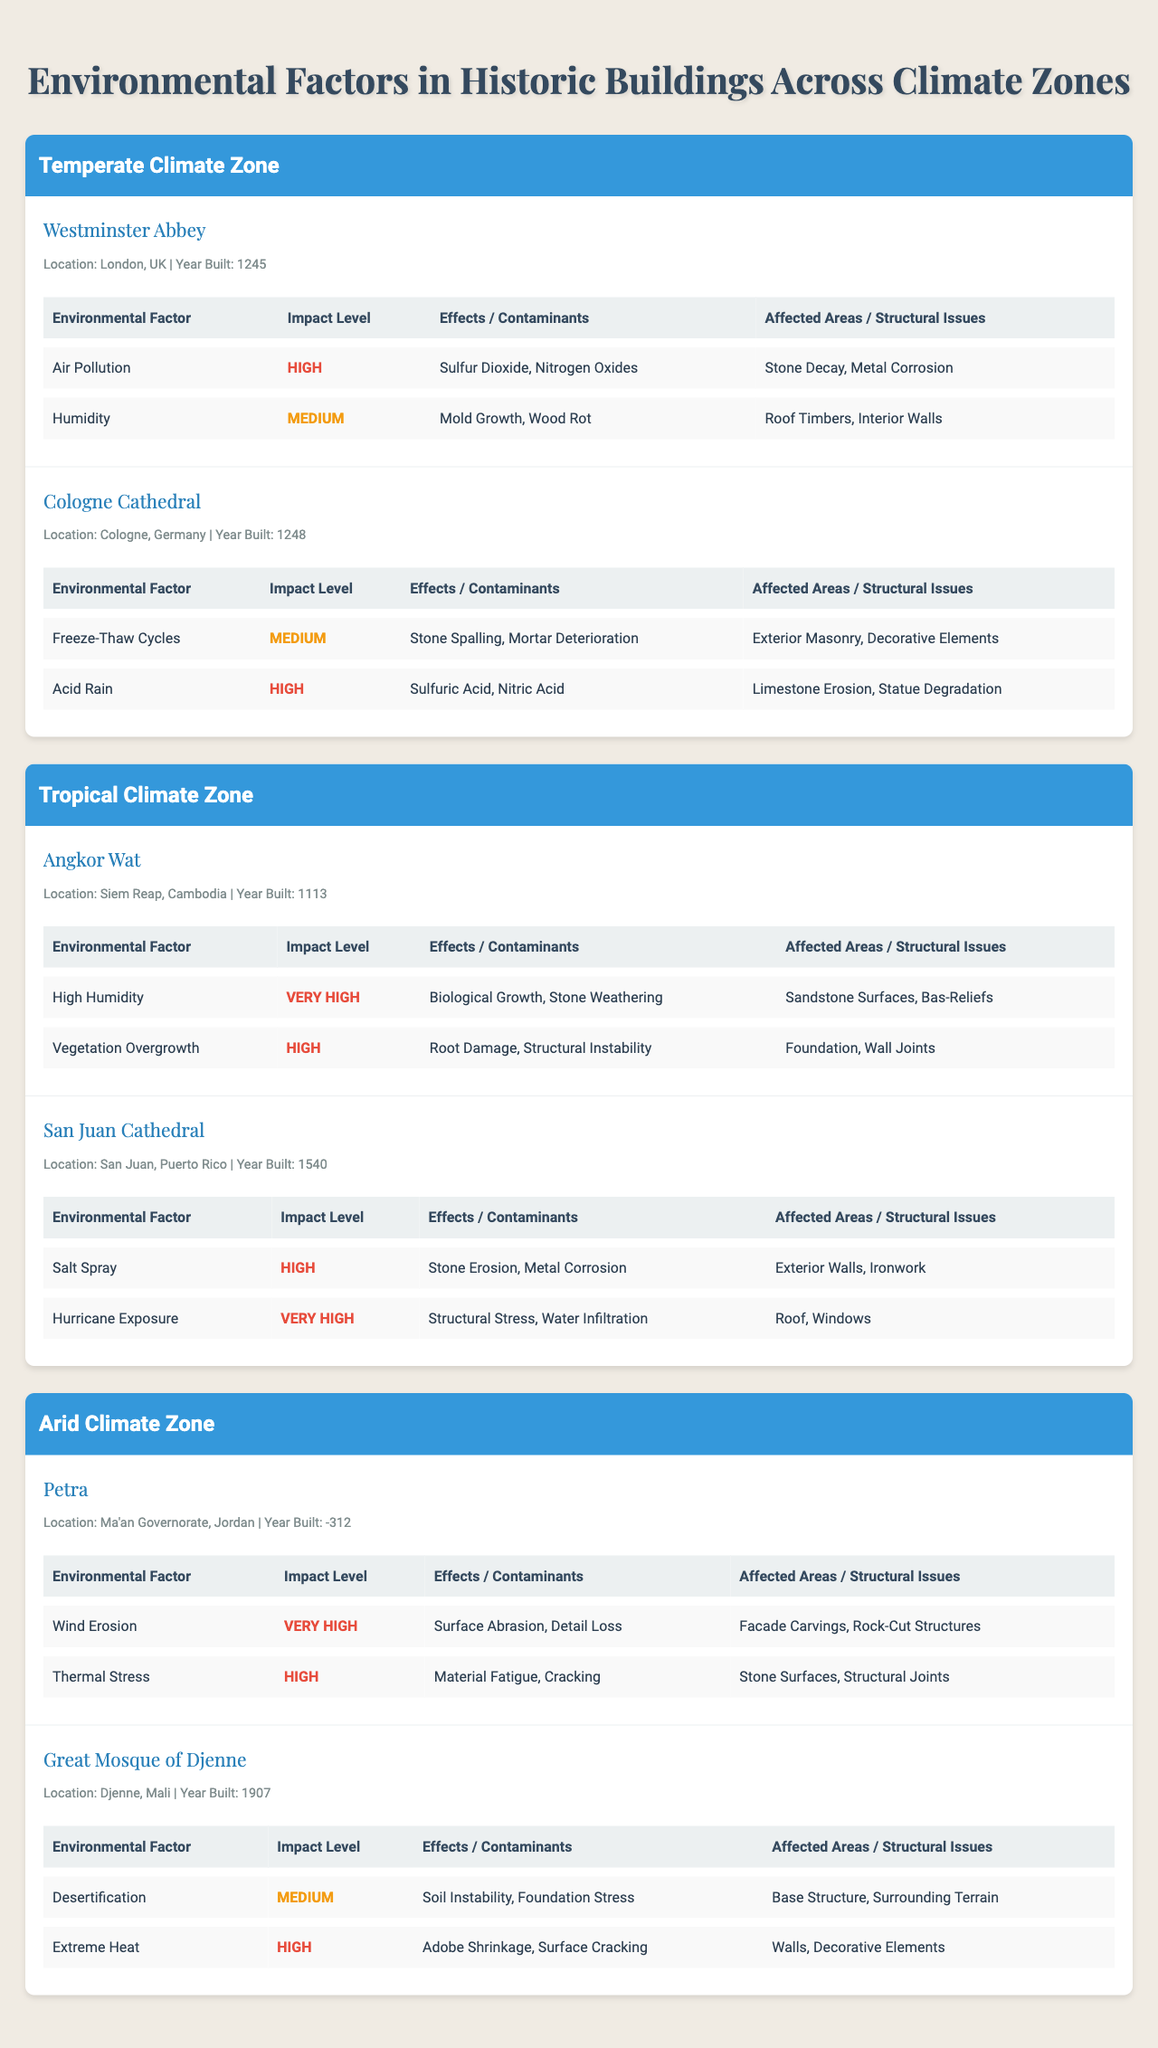What is the highest impact level for environmental factors affecting Westminster Abbey? The table shows that Westminster Abbey has two environmental factors: "Air Pollution" with a "High" impact level and "Humidity" with a "Medium" impact level. The highest impact level here is "High."
Answer: High Which building was built earlier, Angkor Wat or Cologne Cathedral? Angkor Wat was built in 1113, while Cologne Cathedral was built in 1248. Since 1113 is earlier than 1248, Angkor Wat is the earlier building.
Answer: Angkor Wat How many buildings in the Tropical climate zone have an environmental factor with a "Very High" impact level? In the Tropical climate zone, Angkor Wat has a "Very High" impact level for "High Humidity," and San Juan Cathedral has "Hurricane Exposure" also at a "Very High" level. Therefore, there are 2 buildings with this designation.
Answer: 2 What is the main contaminant associated with the "Acid Rain" environmental factor for Cologne Cathedral? The table indicates that the main contaminants for "Acid Rain" impacting Cologne Cathedral are "Sulfuric Acid" and "Nitric Acid." So, the main contaminants are both listed.
Answer: Sulfuric Acid, Nitric Acid For the Arid climate zone, what structural issue is associated with "Wind Erosion" for Petra? According to the table, the structural issues caused by "Wind Erosion" for Petra include "Surface Abrasion" and "Detail Loss."
Answer: Surface Abrasion, Detail Loss Is "High Humidity" considered a critical environmental factor for Angkor Wat? The impact level for "High Humidity" affecting Angkor Wat is classified as "Very High." Therefore, it is indeed considered a critical environmental factor.
Answer: Yes Which climate zone has buildings that have been affected by "Hurricane Exposure"? The Tropical climate zone is the one where "Hurricane Exposure" is listed as an environmental factor for San Juan Cathedral.
Answer: Tropical How many different environmental factors affect the Great Mosque of Djenne? There are two environmental factors listed for the Great Mosque of Djenne: "Desertification" and "Extreme Heat." Therefore, it is affected by two different factors.
Answer: 2 What are the effects of "Salt Spray" on the San Juan Cathedral? The table shows that "Salt Spray" affects the San Juan Cathedral by causing "Stone Erosion" and "Metal Corrosion."
Answer: Stone Erosion, Metal Corrosion Which historic building has structural issues specifically related to "Acid Rain"? The Cologne Cathedral has structural issues related to "Acid Rain," which includes "Limestone Erosion" and "Statue Degradation."
Answer: Cologne Cathedral 